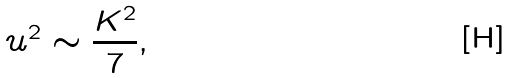<formula> <loc_0><loc_0><loc_500><loc_500>u ^ { 2 } \sim \frac { K ^ { 2 } } { 7 } ,</formula> 